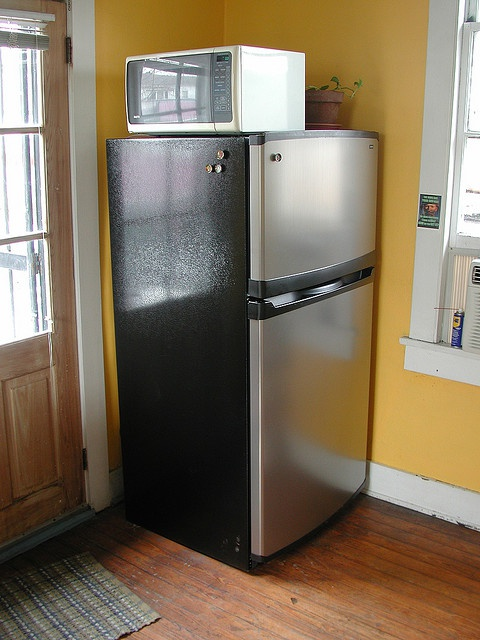Describe the objects in this image and their specific colors. I can see refrigerator in gray, black, darkgray, and lightgray tones, microwave in gray, white, darkgray, and olive tones, and potted plant in gray, maroon, olive, and black tones in this image. 